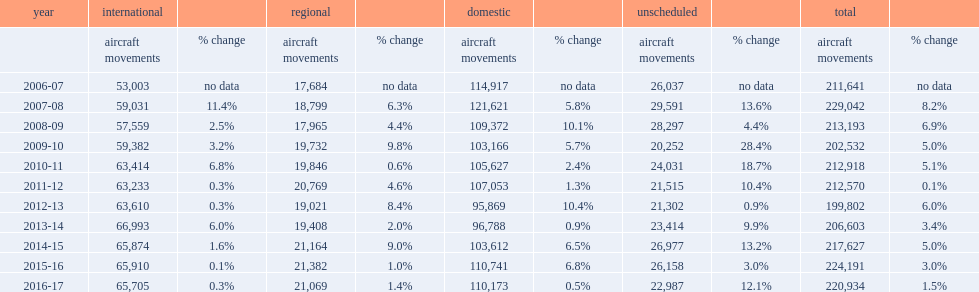How many aircraft movements did the o. r. tambo international airport have? 212918.0. 